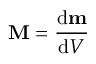<formula> <loc_0><loc_0><loc_500><loc_500>M = { \frac { d m } { d V } }</formula> 